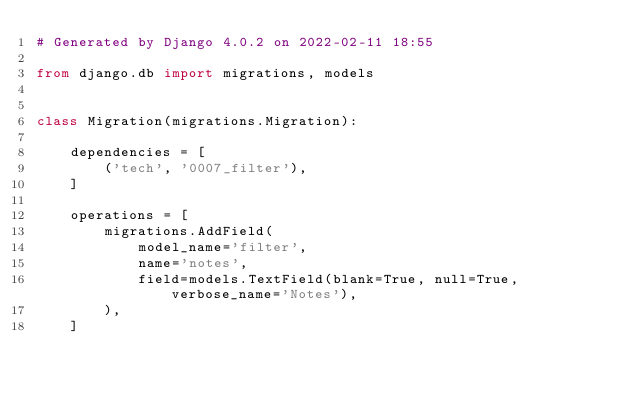<code> <loc_0><loc_0><loc_500><loc_500><_Python_># Generated by Django 4.0.2 on 2022-02-11 18:55

from django.db import migrations, models


class Migration(migrations.Migration):

    dependencies = [
        ('tech', '0007_filter'),
    ]

    operations = [
        migrations.AddField(
            model_name='filter',
            name='notes',
            field=models.TextField(blank=True, null=True, verbose_name='Notes'),
        ),
    ]
</code> 